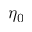<formula> <loc_0><loc_0><loc_500><loc_500>\eta _ { 0 }</formula> 